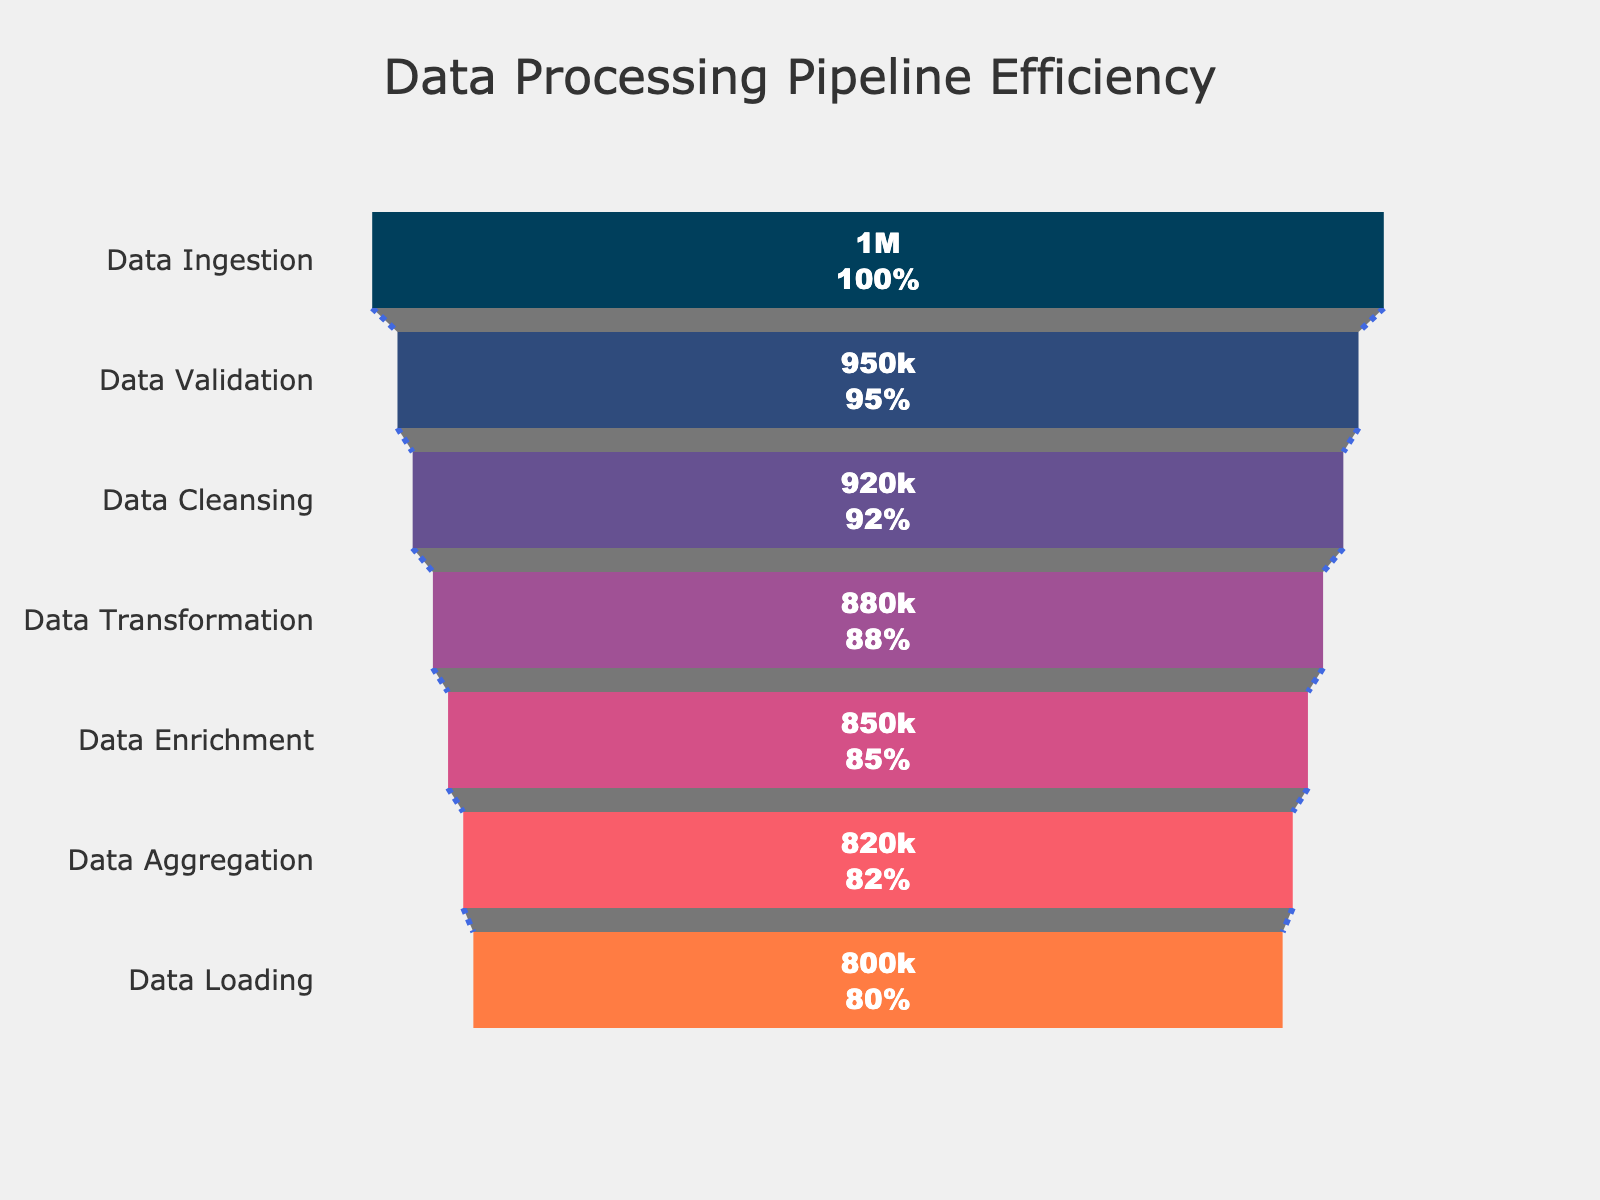what is the title of the Funnel Chart? The title of the chart is displayed at the top center of the figure.
Answer: "Data Processing Pipeline Efficiency" Which step processes the highest number of records? Look at the step with the largest bar at the top of the funnel chart.
Answer: Data Ingestion What percentage of records are successfully loaded compared to the number of records ingested? Find the percentage value associated with the Data Loading step relative to Data Ingestion.
Answer: 80% Calculate the difference in the number of records processed between Data Validation and Data Transformation steps. Subtract the number of records processed in Data Transformation from the number of records processed in Data Validation. 950,000 - 880,000 = 70,000
Answer: 70,000 Which step sees the largest drop in records processed, and what is the value of that drop? Identify the two steps with the largest difference in records processed by comparing adjacent values, then calculate the difference. The largest drop is between Data Validation (950,000) and Data Cleansing (920,000), which is 950,000 - 920,000 = 30,000
Answer: Data Validation to Data Cleansing, 30,000 Compare the percentage drop from Data Ingestion to Data Aggregation. Calculate the difference in percentage from Data Ingestion (100%) to Data Aggregation (82%). 100% - 82% = 18%
Answer: 18% How does the proportion of records processed change from Data Transformation to Data Enrichment? Look at the percentage values for Data Transformation (88%) and Data Enrichment (85%), then calculate the difference. 88% - 85% = 3%
Answer: 3% What is the average percentage of records processed across all steps? Sum all percentages and divide by the number of steps. (100% + 95% + 92% + 88% + 85% + 82% + 80%) / 7 ≈ 88.86%
Answer: ~88.86% If you need to improve a step, which one would you prioritize based on the drop in records processed, and why? Prioritize the step with the largest observed drop. The largest drop is from Data Validation to Data Cleansing (30,000 records).
Answer: Data Cleansing Identify the color of the bar representing the Data Transformation step. Examine the color scheme associated with the funnel chart specifically for the Data Transformation step.
Answer: Purple 